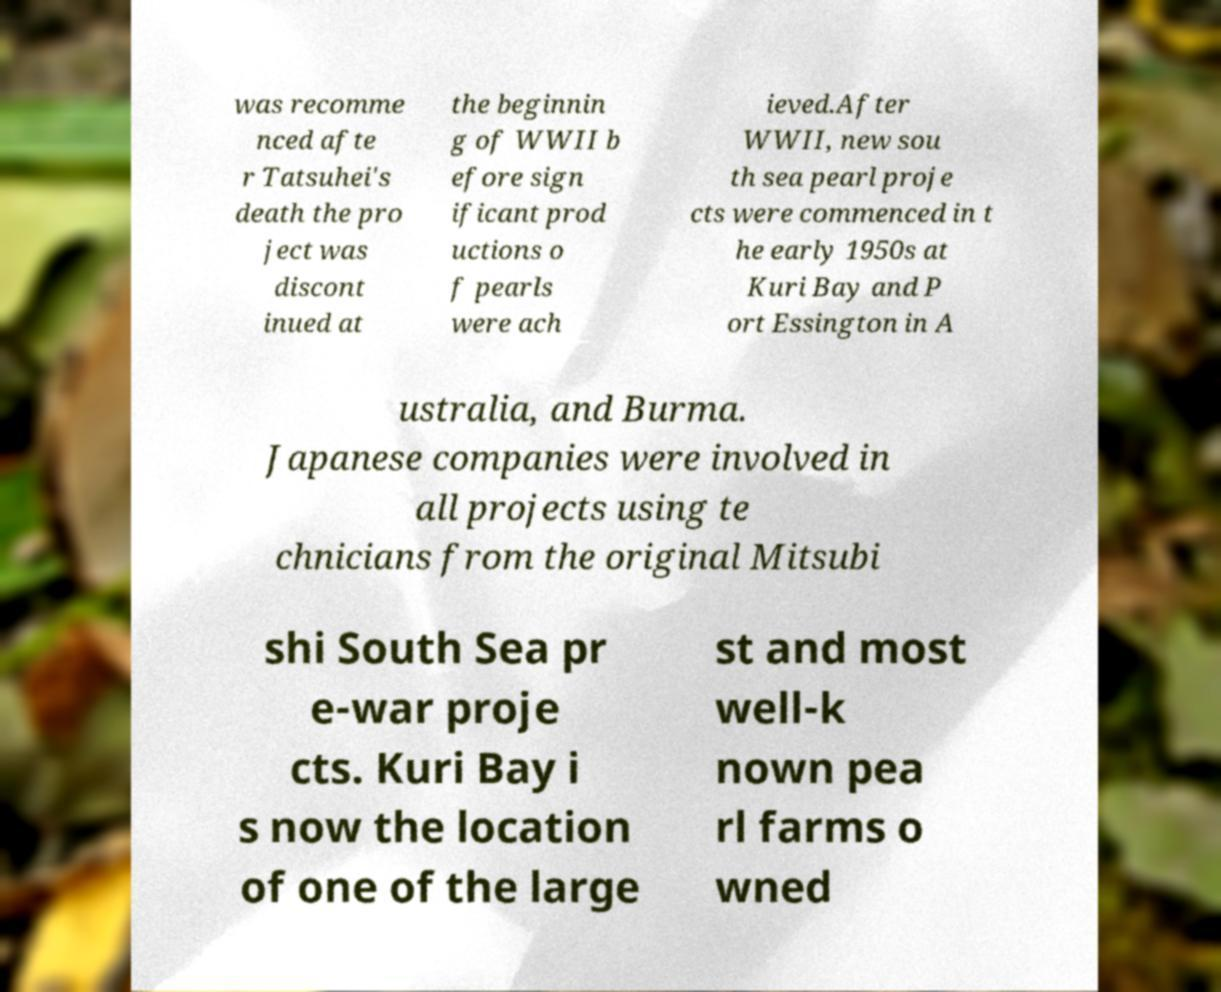Can you accurately transcribe the text from the provided image for me? was recomme nced afte r Tatsuhei's death the pro ject was discont inued at the beginnin g of WWII b efore sign ificant prod uctions o f pearls were ach ieved.After WWII, new sou th sea pearl proje cts were commenced in t he early 1950s at Kuri Bay and P ort Essington in A ustralia, and Burma. Japanese companies were involved in all projects using te chnicians from the original Mitsubi shi South Sea pr e-war proje cts. Kuri Bay i s now the location of one of the large st and most well-k nown pea rl farms o wned 